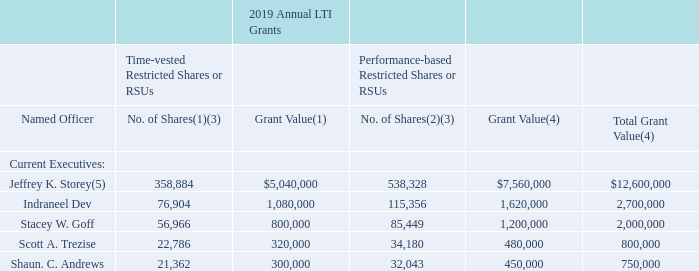2019 Annual LTI Grants. Except for Messrs. Dev, Trezise and Andrews, the Committee granted annual LTI
awards to our named executives in February 2019 at amounts substantially similar to the awards granted to
them in 2018. Mr. Dev’s 2019 LTI target was increased to $2,700,000, as previously approved by the Committee
upon his promotion to CFO in November 2018. Mr. Andrews’ 2019 LTI target was increased to $750,000, as
previously approved by the Committee following a review of compensation benchmarking in November 2018. In
February 2019, the Committee reviewed the compensation benchmarking data for all executive officers and
increased Mr. Trezise’s LTI target to $800,000 and left unchanged the LTI target for our other NEOs.
On February 28, 2019, the Committee granted our named executives the following number of (i) restricted shares or RSUs that will vest over a three-year period principally in exchange for continued service (“time-vested restricted shares or RSUs”), (ii) performance-based restricted shares or RSUs that will vest in two equal installments on March 1 of each of 2021 and 2022 based on attainment during the 2019 Performance Period, as defined above, of an Adjusted EBITDA Run Rate target of 0.0% (the “Performance-Vested Shares or RSUs”), as described further above:
(1) Represents the number of restricted shares or RSUs granted in 2019.
(2) As discussed further above, the actual number of shares that vest in the future may be lower or higher, depending on the level of performance achieved.
(3) Dividends on the shares of restricted stock (or, with respect to RSUs, dividend equivalents) will not be paid while unvested, but will accrue and paid or be forfeited in tandem with the vesting of the related shares or RSUs.
(4) For purposes of these grants, we determined both the number of time-vested and performance-based restricted shares or RSUs by dividing the total grant value granted to the executive by the volume-weighted average closing price of a share of our common stock over the 15-trading-day period ending five trading days prior to the grant date (“VWAP”), rounding to the nearest whole share. However, as noted previously, for purposes of reporting these awards in the Summary Compensation Table, our shares of time-vested restricted stock or RSUs are valued based on the closing price of our common stock on the date of grant and our shares of performance-based restricted stock or RSUs are valued as of the grant date based on probable outcomes, as required by applicable accounting and SEC disclosure rules. See footnote 2 to the Summary Compensation Table for more information.
(5) Mr. Storey’s annual grant was in the form of RSUs.
What form was Jeffrey K. Storey's annual grant? In the form of rsus. How was the number of time-vested and performance-based restricted shares or RSUs determined? By dividing the total grant value granted to the executive by the volume-weighted average closing price of a share of our common stock over the 15-trading-day period ending five trading days prior to the grant date (“vwap”), rounding to the nearest whole share. Which current executives had their LTI targets increased? Indraneel dev, shaun. c. andrews, scott a. trezise. How many current executives have a total grant value above $2,000,000? Jeffrey K. Storey##Indraneel Dev
Answer: 2. What is the difference between Indraneel Dev and Stacey W. Goff's total grant values? $2,700,000-$2,000,000
Answer: 700000. What is the average total grant value for current executives? ($12,600,000+$2,700,000+$2,000,000+$800,000+$750,000)/5
Answer: 3770000. 